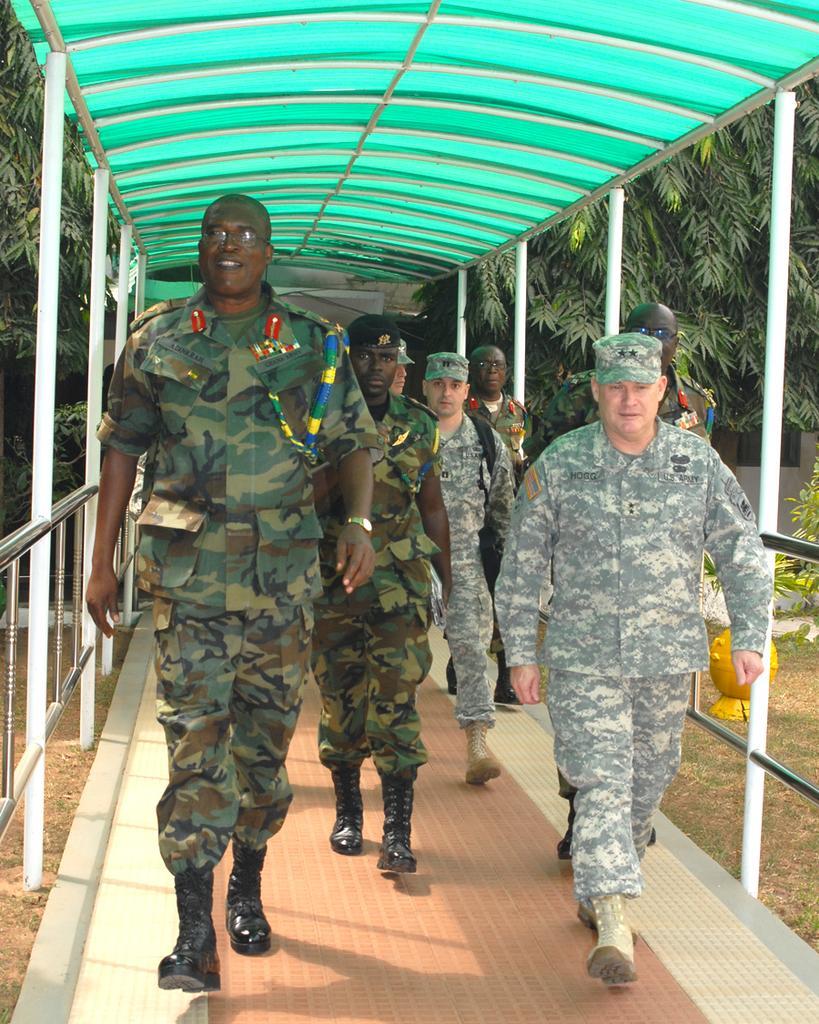How would you summarize this image in a sentence or two? In the image there are few men in camouflage dress walking under a shed with trees behind it. 